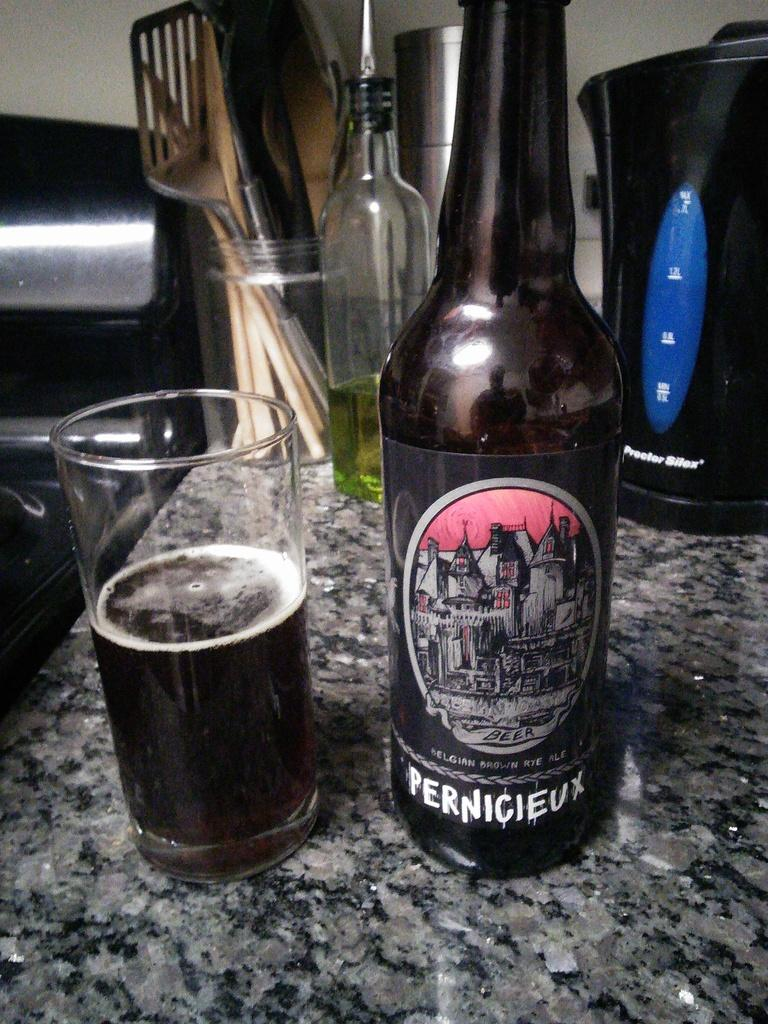What type of furniture is present in the image? There is a table in the image. What is placed on the table? There is an alcohol bottle, a glass with a cool drink, a glass bottle, and a box with many spoons on the table. Is there any seating near the table? Yes, there is a chair beside the table. What type of crime is being committed in the image? There is no indication of any crime being committed in the image. The image only shows a table with various items and a chair beside it. 